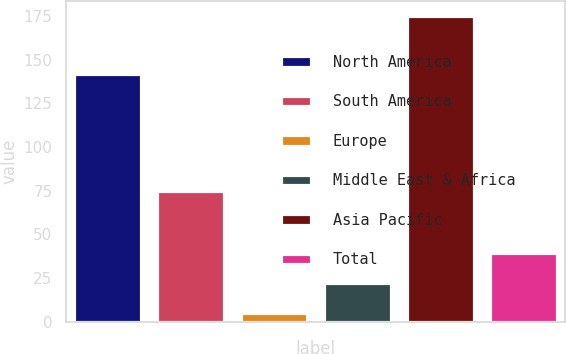Convert chart. <chart><loc_0><loc_0><loc_500><loc_500><bar_chart><fcel>North America<fcel>South America<fcel>Europe<fcel>Middle East & Africa<fcel>Asia Pacific<fcel>Total<nl><fcel>142<fcel>75<fcel>5<fcel>22<fcel>175<fcel>39<nl></chart> 